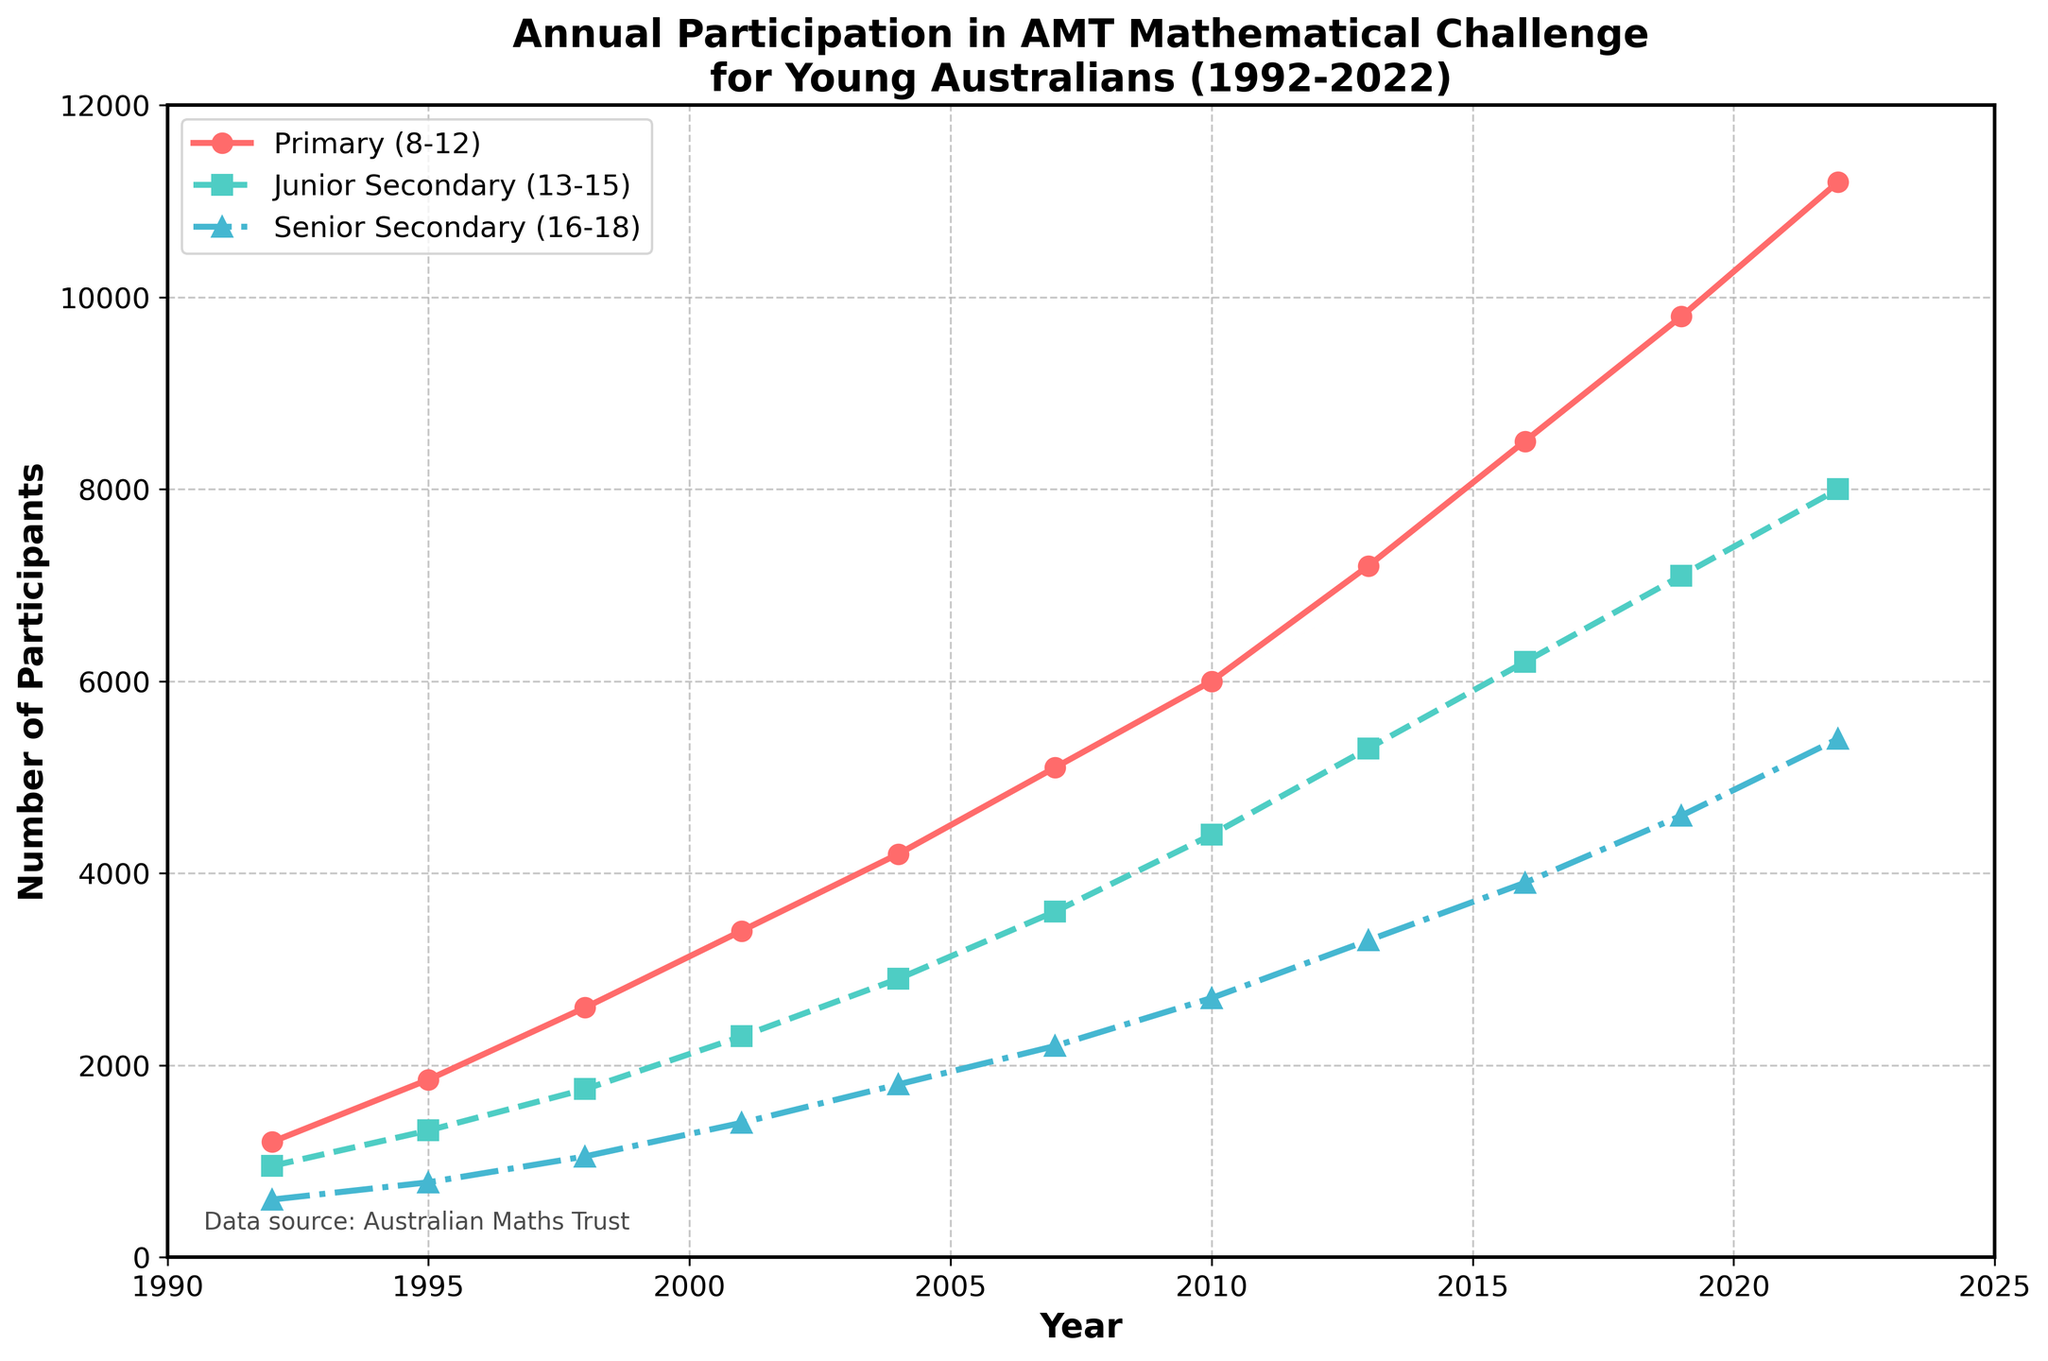what is the largest increase in the number of participants in the Primary age group between any two consecutive years? Find the difference between the number of participants for each pair of consecutive years in the Primary age group and identify the largest. For example, from 1992 to 1995, the difference is 1850 - 1200 = 650. The largest increase is from 2019 to 2022: 11200 - 9800 = 1400
Answer: 1400 How did the total participation change from 1992 to 2022 across all age groups? Sum the participation across all age groups for the years 1992 and 2022, and then find the difference. For 1992: 1200 + 950 + 600 = 2750. For 2022: 11200 + 8000 + 5400 = 24600. The change is 24600 - 2750 = 21850
Answer: 21850 Which age group showed the most consistent increase over the years? Examine the trends in the graph; the Primary age group shows a relative linear and consistent increase compared to Junior and Senior Secondary groups, which exhibit more fluctuations
Answer: Primary (8-12) Did any age group experience a year where the number of participants decreased compared to the previous year? Analyze the trends for each age group. All age groups show a steadily increasing trend with no visible decrease any year
Answer: No By how much did the participation for the Senior Secondary age group increase from 2001 to 2010? Compare the number of participants in Senior Secondary (16-18) between 2001 and 2010. The increase is 2700 - 1400 = 1300
Answer: 1300 What is the average number of participants in the Junior Secondary age group over the period? Sum the participants in the Junior Secondary age group for all years and divide by the number of years. (950 + 1320 + 1750 + 2300 + 2900 + 3600 + 4400 + 5300 + 6200 + 7100 + 8000)/11 = 4720
Answer: 4720 Which year showed the highest combined participation for all age groups? Sum the participants of all age groups for each year and compare to find the highest. In 2022 the combined participants are 11200 + 8000 + 5400 = 24600, which is the highest
Answer: 2022 How does the participation in 2022 for the Junior Secondary age group compare to the Primary age group in 2004? Compare the number of participants in the Junior Secondary age group in 2022 (8000) with those in the Primary age group in 2004 (4200). The Junior Secondary in 2022 has a higher number.
Answer: Junior Secondary (2022) What was the total participation in the program in the year 2007? Sum the number of participants across all age groups for the year 2007: 5100 + 3600 + 2200 = 10900
Answer: 10900 